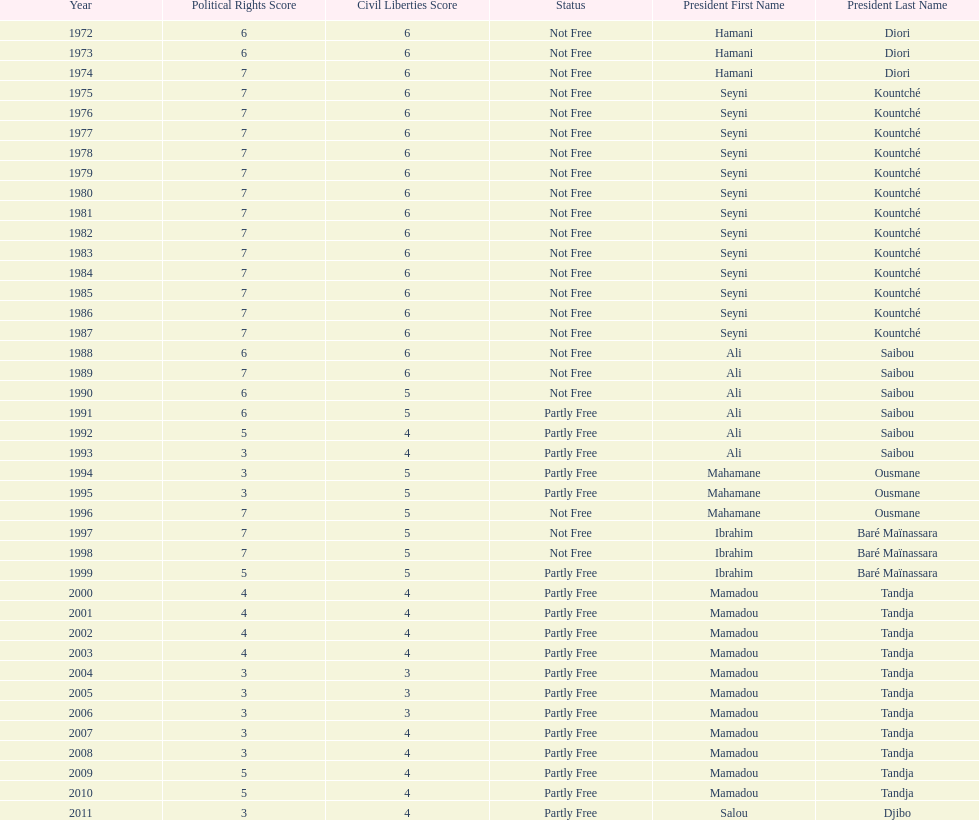What is the number of time seyni kountche has been president? 13. 